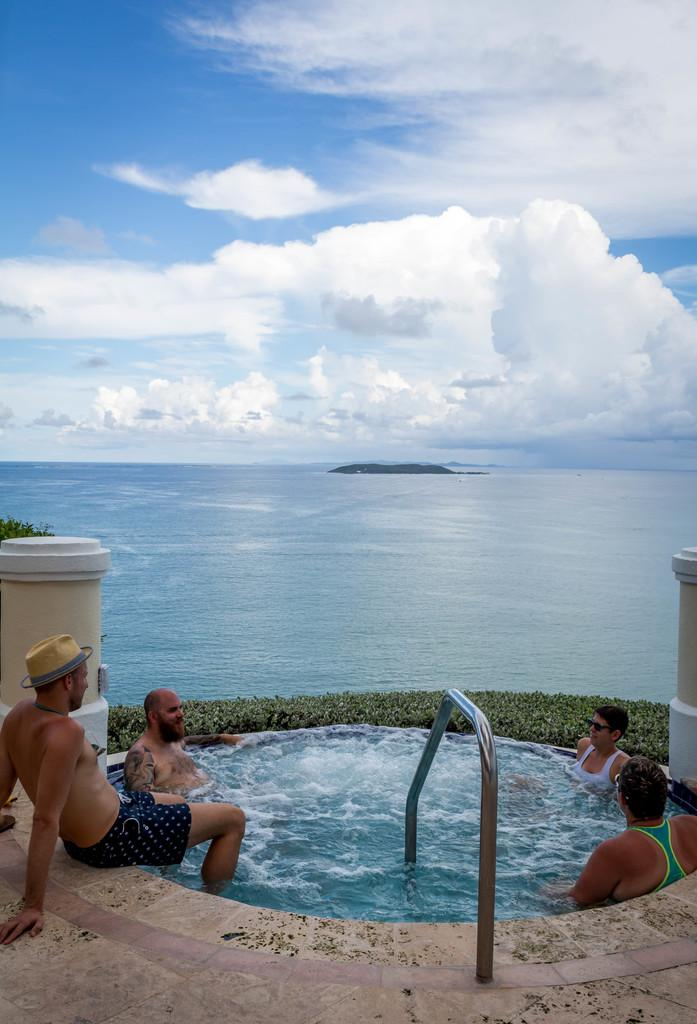How many people are in the pool in the image? There are three persons in a pool in the image. What is the person doing who is not in the pool? There is another person sitting beside the pool. What type of vegetation can be seen in the image? There are plants visible in the image. What is the primary element in the image? There is water in the image, which is the pool. What can be seen in the sky in the image? The sky is visible in the image. What type of cream is being applied to the coat of the dog in the image? There is no dog or cream present in the image. 